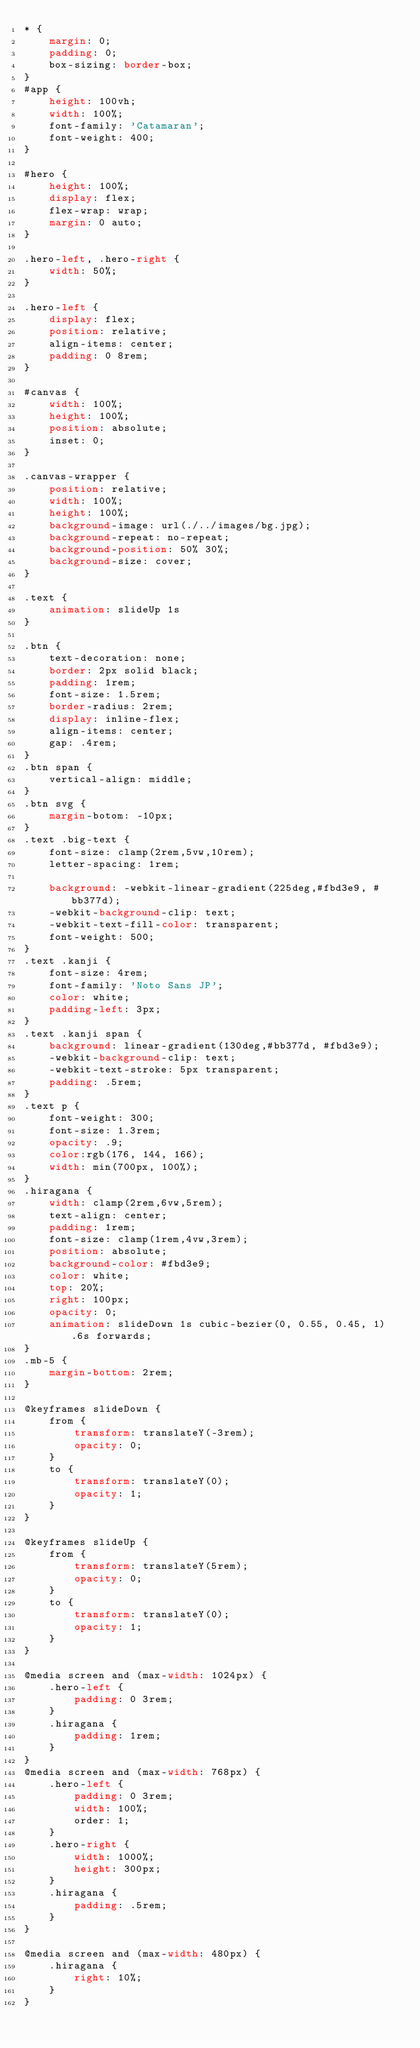Convert code to text. <code><loc_0><loc_0><loc_500><loc_500><_CSS_>* {
    margin: 0;
    padding: 0;
    box-sizing: border-box;
}
#app {
    height: 100vh;
    width: 100%;
    font-family: 'Catamaran';
    font-weight: 400;
}

#hero {
    height: 100%;
    display: flex;
    flex-wrap: wrap;
    margin: 0 auto;
}

.hero-left, .hero-right {
    width: 50%;
}

.hero-left {
    display: flex;
    position: relative;
    align-items: center;
    padding: 0 8rem;
}

#canvas {
    width: 100%;
    height: 100%;
    position: absolute;
    inset: 0;
}

.canvas-wrapper {
    position: relative;
    width: 100%;
    height: 100%;
    background-image: url(./../images/bg.jpg);
    background-repeat: no-repeat;
    background-position: 50% 30%;
    background-size: cover;
}

.text {
    animation: slideUp 1s 
}

.btn {
    text-decoration: none;
    border: 2px solid black;
    padding: 1rem;
    font-size: 1.5rem;
    border-radius: 2rem;
    display: inline-flex;
    align-items: center;
    gap: .4rem;
}
.btn span {
    vertical-align: middle;
}
.btn svg {
    margin-botom: -10px;
}
.text .big-text {
    font-size: clamp(2rem,5vw,10rem);
    letter-spacing: 1rem;

    background: -webkit-linear-gradient(225deg,#fbd3e9, #bb377d);
    -webkit-background-clip: text;
    -webkit-text-fill-color: transparent;
    font-weight: 500;
}
.text .kanji {
    font-size: 4rem;
    font-family: 'Noto Sans JP';
    color: white;
    padding-left: 3px;
}
.text .kanji span {
    background: linear-gradient(130deg,#bb377d, #fbd3e9);
    -webkit-background-clip: text;
    -webkit-text-stroke: 5px transparent;
    padding: .5rem;
}
.text p {
    font-weight: 300;
    font-size: 1.3rem;
    opacity: .9;
    color:rgb(176, 144, 166);
    width: min(700px, 100%);
}
.hiragana {
    width: clamp(2rem,6vw,5rem);
    text-align: center;
    padding: 1rem;
    font-size: clamp(1rem,4vw,3rem);
    position: absolute;
    background-color: #fbd3e9;
    color: white;
    top: 20%;
    right: 100px;
    opacity: 0;
    animation: slideDown 1s cubic-bezier(0, 0.55, 0.45, 1) .6s forwards;
}
.mb-5 {
    margin-bottom: 2rem;
}

@keyframes slideDown {
    from {
        transform: translateY(-3rem);
        opacity: 0;
    }
    to {
        transform: translateY(0);
        opacity: 1;
    }
}

@keyframes slideUp {
    from {
        transform: translateY(5rem);
        opacity: 0;
    }
    to {
        transform: translateY(0);
        opacity: 1;
    }
}

@media screen and (max-width: 1024px) {
    .hero-left {
        padding: 0 3rem;
    }
    .hiragana {
        padding: 1rem;
    }
}
@media screen and (max-width: 768px) {
    .hero-left {
        padding: 0 3rem;
        width: 100%;
        order: 1;
    }
    .hero-right {
        width: 1000%;
        height: 300px;
    }
    .hiragana {
        padding: .5rem;
    }
}

@media screen and (max-width: 480px) {
    .hiragana {
        right: 10%;
    }
}</code> 